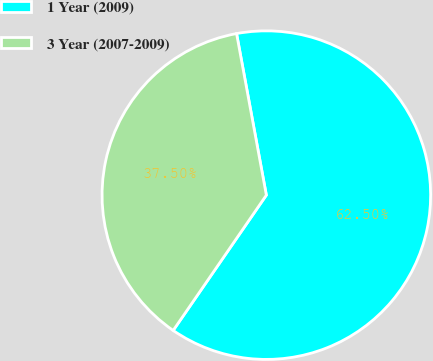<chart> <loc_0><loc_0><loc_500><loc_500><pie_chart><fcel>1 Year (2009)<fcel>3 Year (2007-2009)<nl><fcel>62.5%<fcel>37.5%<nl></chart> 